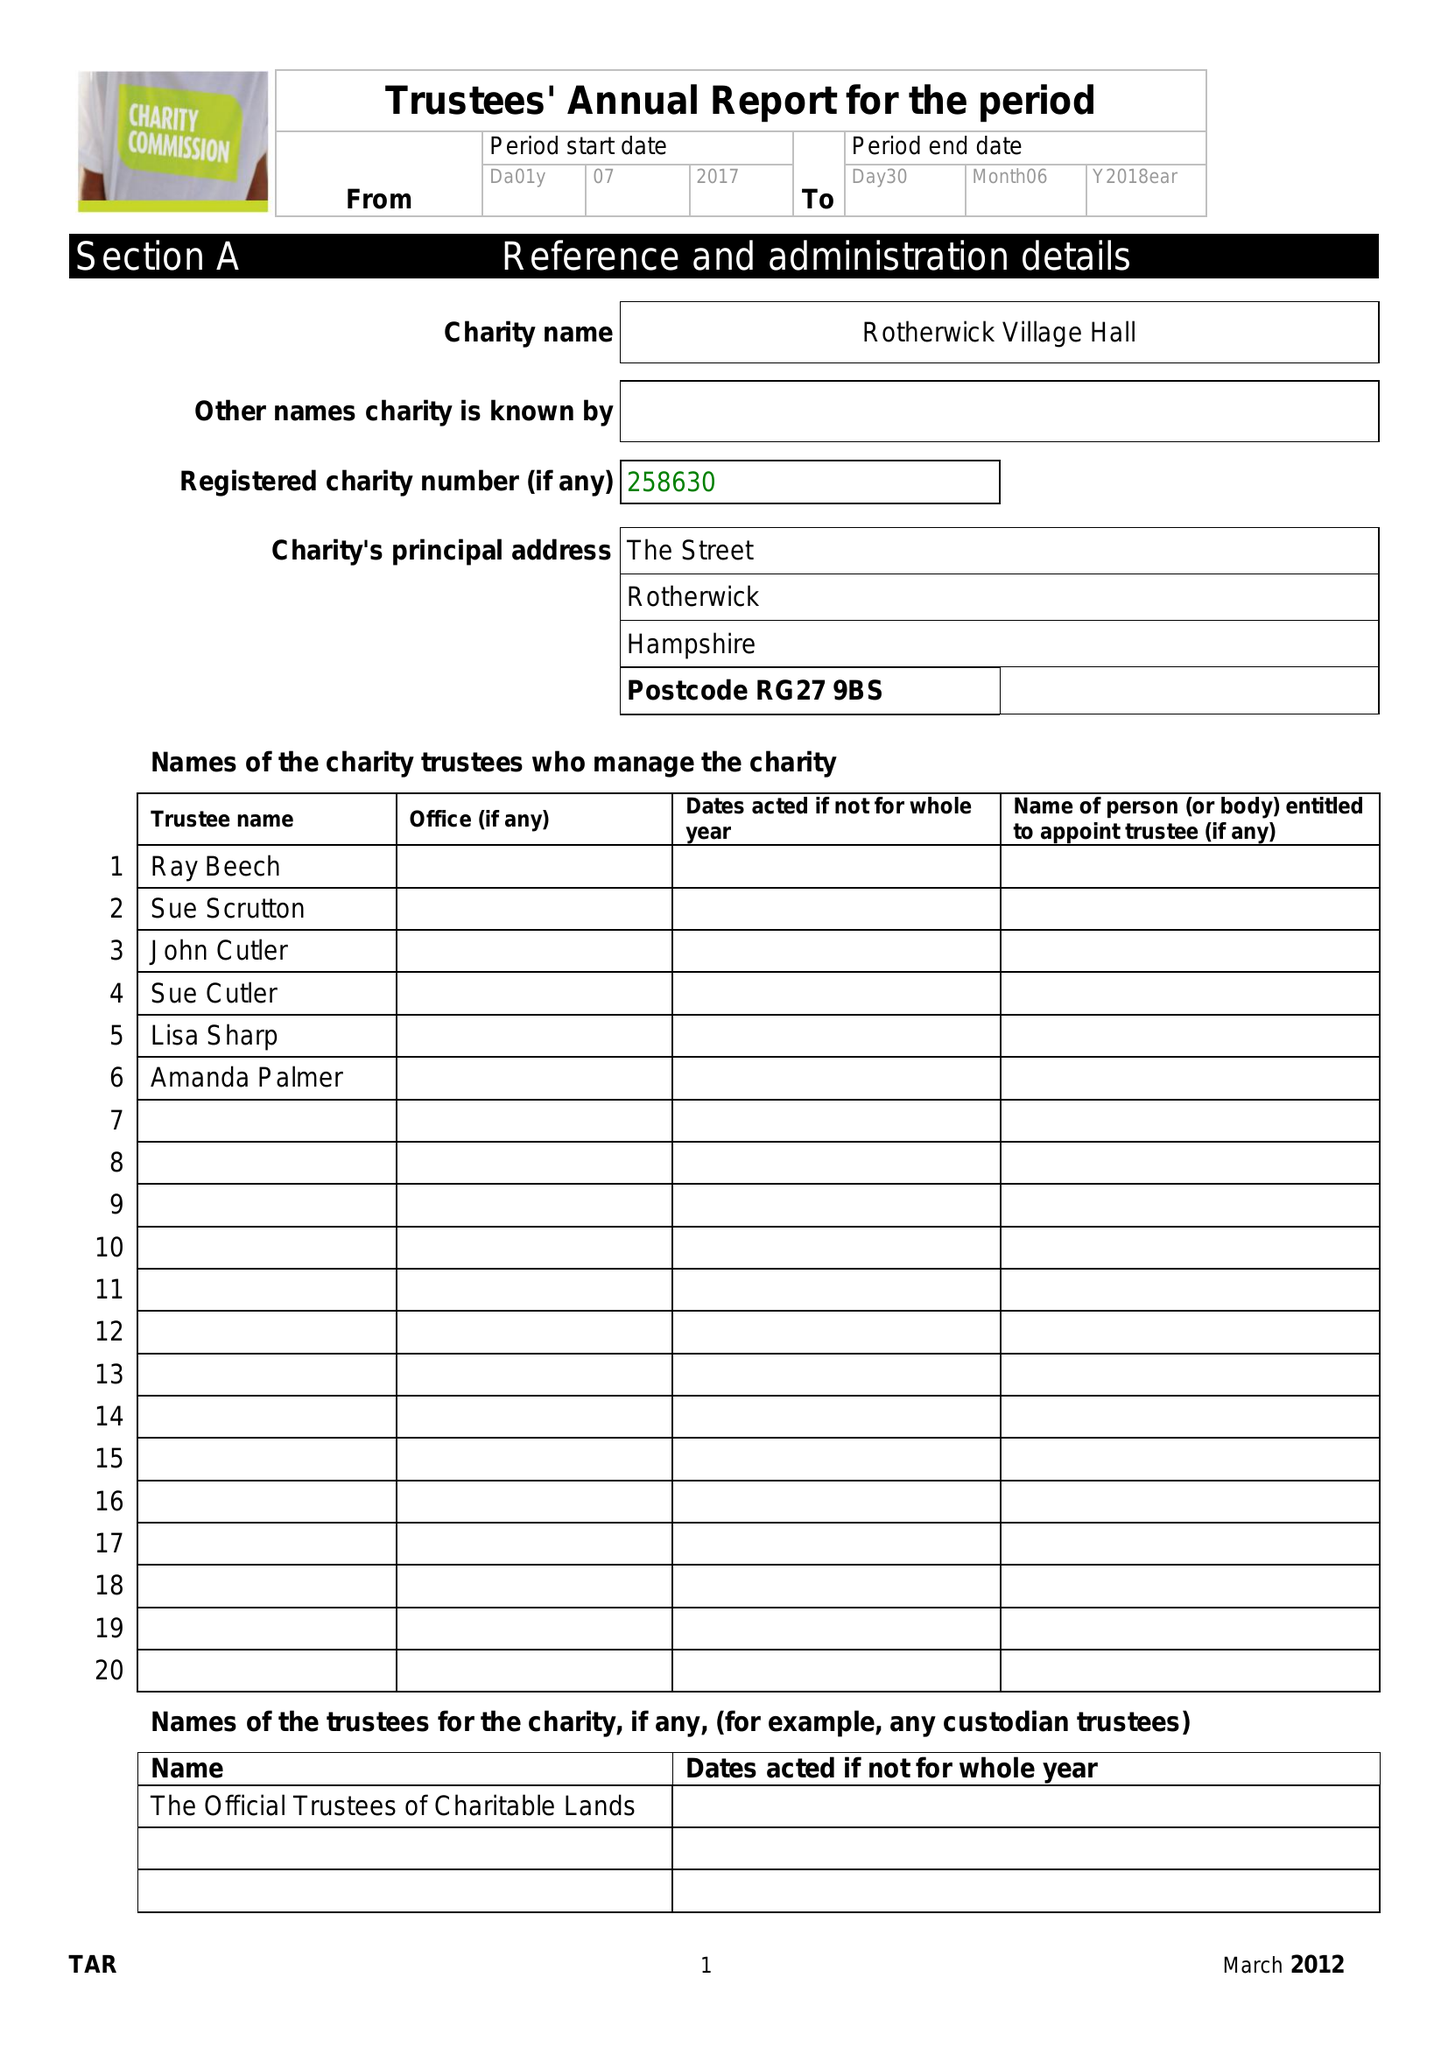What is the value for the report_date?
Answer the question using a single word or phrase. 2018-06-30 